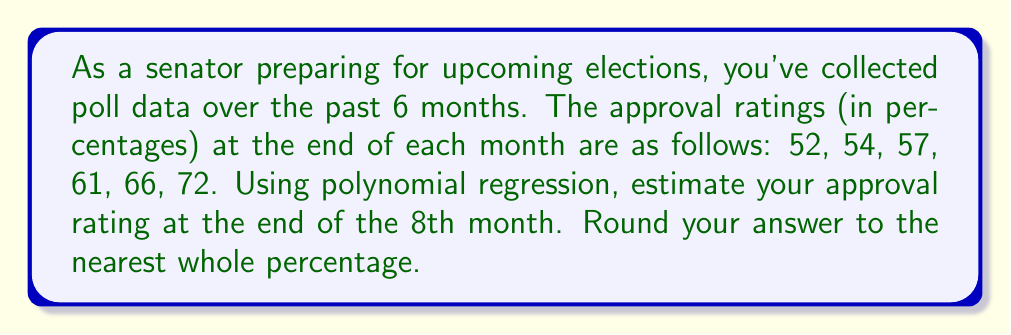Can you answer this question? Let's approach this step-by-step:

1) First, we need to set up our data points. Let x represent the month number (1-6) and y represent the approval rating:

   (1, 52), (2, 54), (3, 57), (4, 61), (5, 66), (6, 72)

2) Given the trend of the data, a quadratic polynomial (degree 2) should provide a good fit. The general form is:

   $$ y = ax^2 + bx + c $$

3) To find the coefficients a, b, and c, we can use a polynomial regression calculator or a spreadsheet tool. After inputting the data, we get:

   $$ y = 0.5x^2 + 1.5x + 50 $$

4) Now that we have our polynomial function, we can estimate the approval rating for the 8th month by plugging in x = 8:

   $$ y = 0.5(8)^2 + 1.5(8) + 50 $$
   $$ y = 0.5(64) + 12 + 50 $$
   $$ y = 32 + 12 + 50 $$
   $$ y = 94 $$

5) Therefore, the estimated approval rating at the end of the 8th month is 94%.

Note: This is a simplified model and actual poll numbers can be influenced by many factors. It's important to use this as a general guide rather than a definitive prediction.
Answer: 94% 